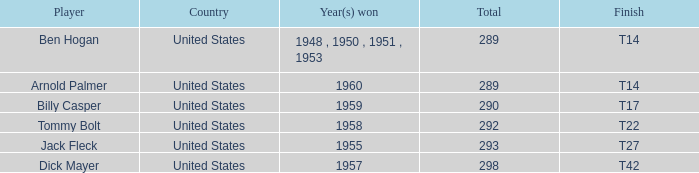What is Player, when Year(s) Won is 1955? Jack Fleck. 